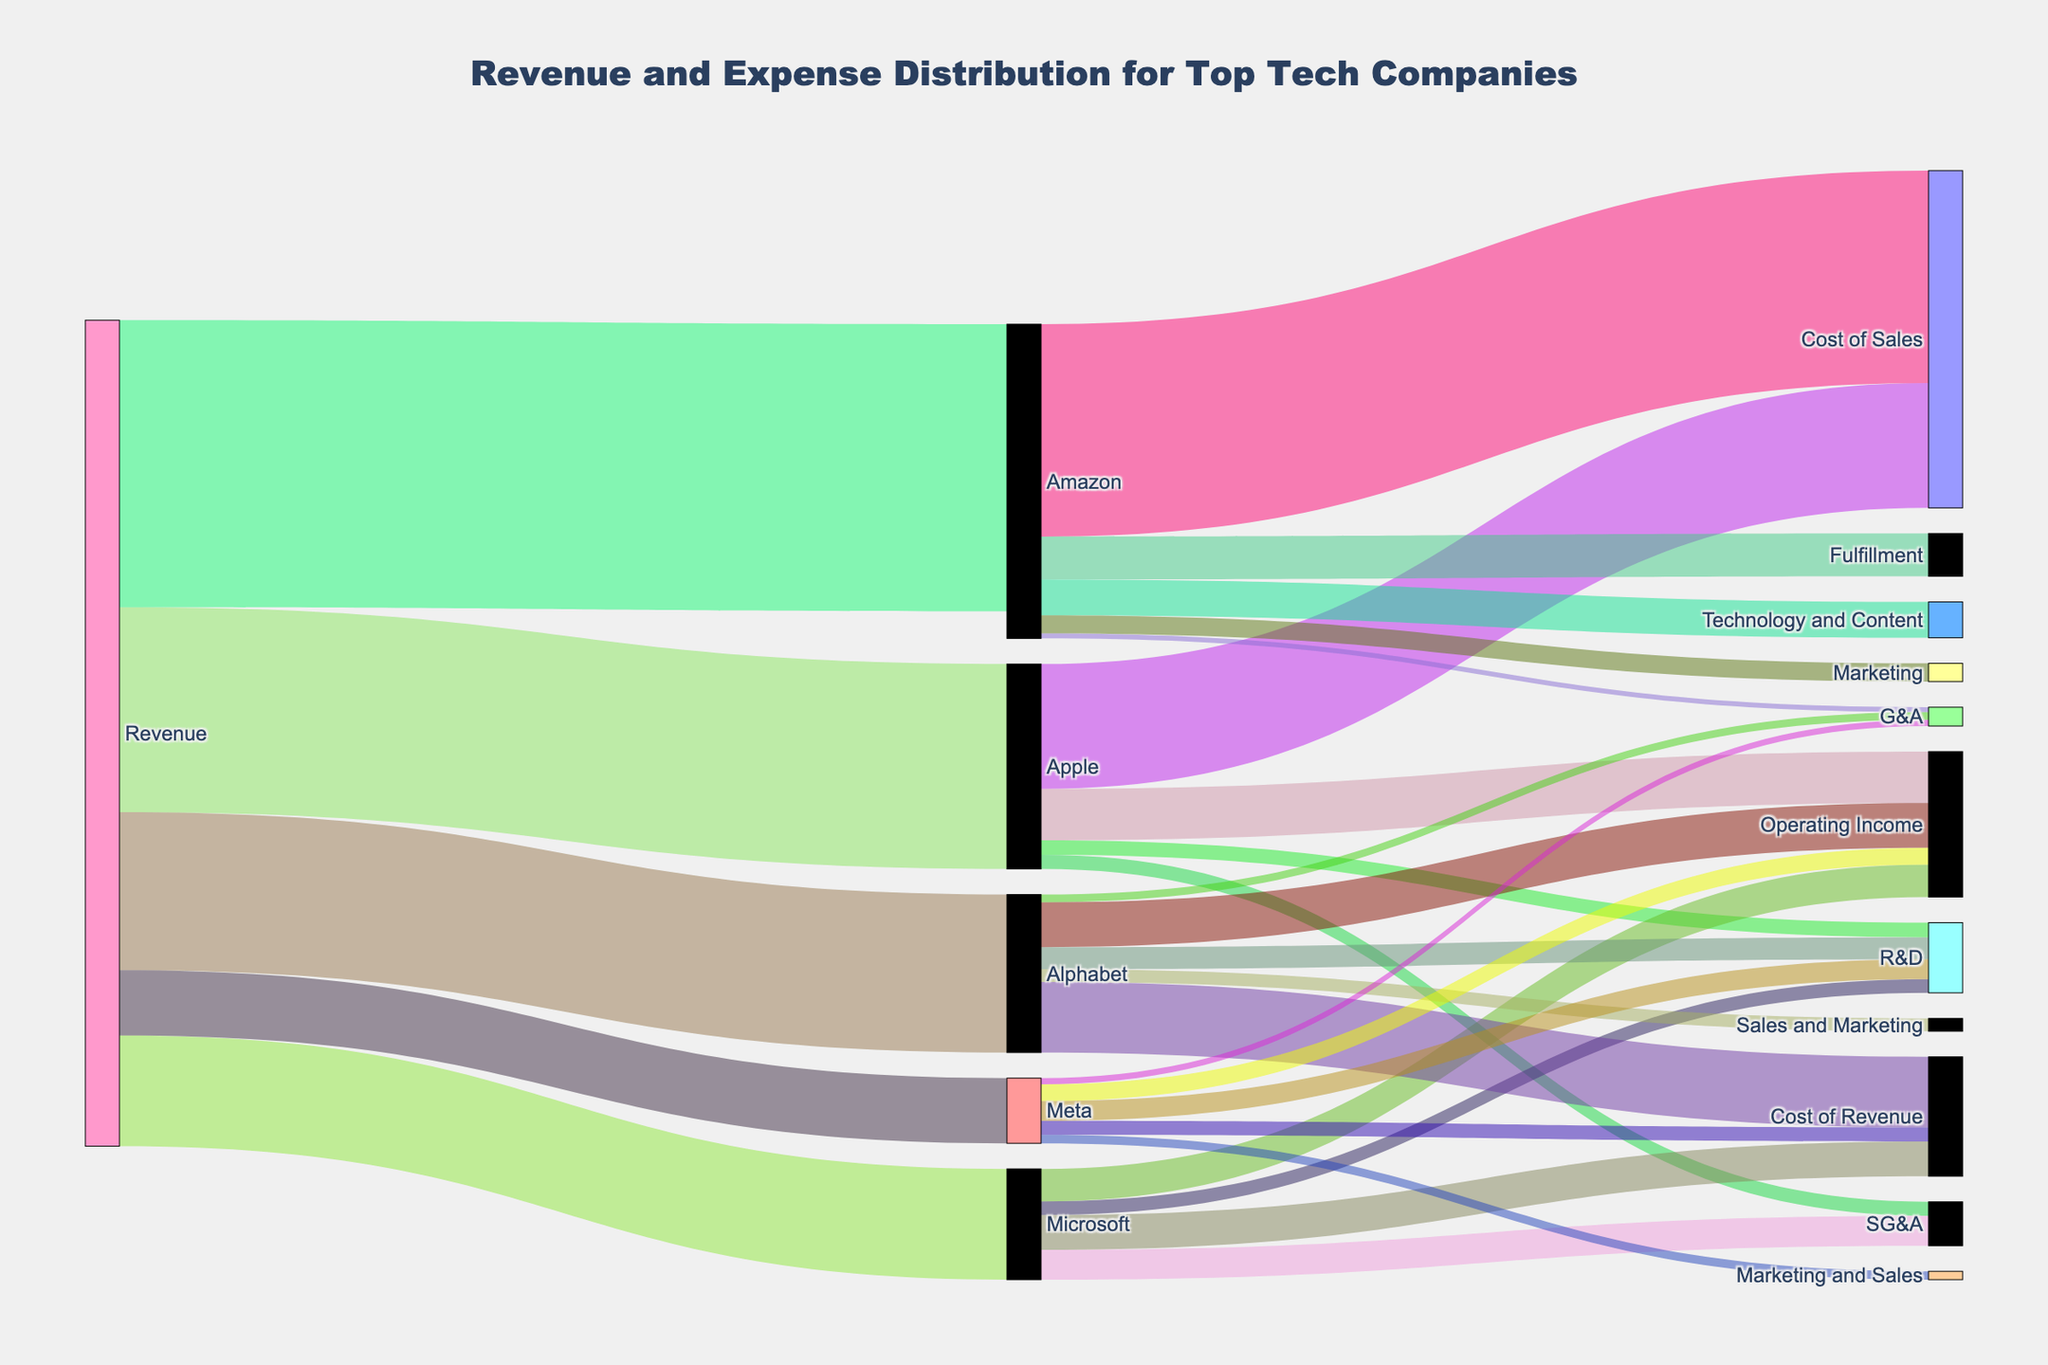How many companies are shown in the revenue streams? Identify how many unique companies appear as targets in the revenue streams from the source "Revenue".
Answer: 5 Which company has the highest revenue stream? Look for the largest value connected to "Revenue" and identify the corresponding company. The highest value (513.9) is for Amazon.
Answer: Amazon What is the total cost of revenue for Microsoft? Sum up the values connected from Microsoft to its cost components. Microsoft has one value connected to Cost of Revenue which is 62.3.
Answer: 62.3 How much more is Apple’s revenue than Meta’s revenue? Subtract the revenue value of Meta (116.6) from Apple’s revenue (366.8).
Answer: 250.2 Which company spends the most on R&D? Identify the company with the highest value directed towards R&D. Apple (26.3), Microsoft (24.5), Amazon (64.2), Alphabet (39.5), Meta (35.4). The highest value is Amazon.
Answer: Amazon What is the operating income of Alphabet? Find the value directed from Alphabet to Operating Income.
Answer: 80.3 What percentage of Apple’s revenue is its operating income? Calculate the percentage by dividing Apple’s Operating Income (91.9) by its revenue (366.8) and multiply by 100.
Answer: 25.1% Which company has a negative operating income and what is that value? Locate the company with a negative value directed towards Operating Income.
Answer: Amazon, -48.5 How does Alphabet’s spending on Cost of Revenue compare to Meta's? Compare the values that are directed from Alphabet to Cost of Revenue (126.2) and Meta to Cost of Revenue (25.2).
Answer: Alphabet spends more 